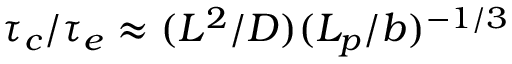<formula> <loc_0><loc_0><loc_500><loc_500>\tau _ { c } / \tau _ { e } \approx ( L ^ { 2 } / D ) ( L _ { p } / b ) ^ { - 1 / 3 }</formula> 